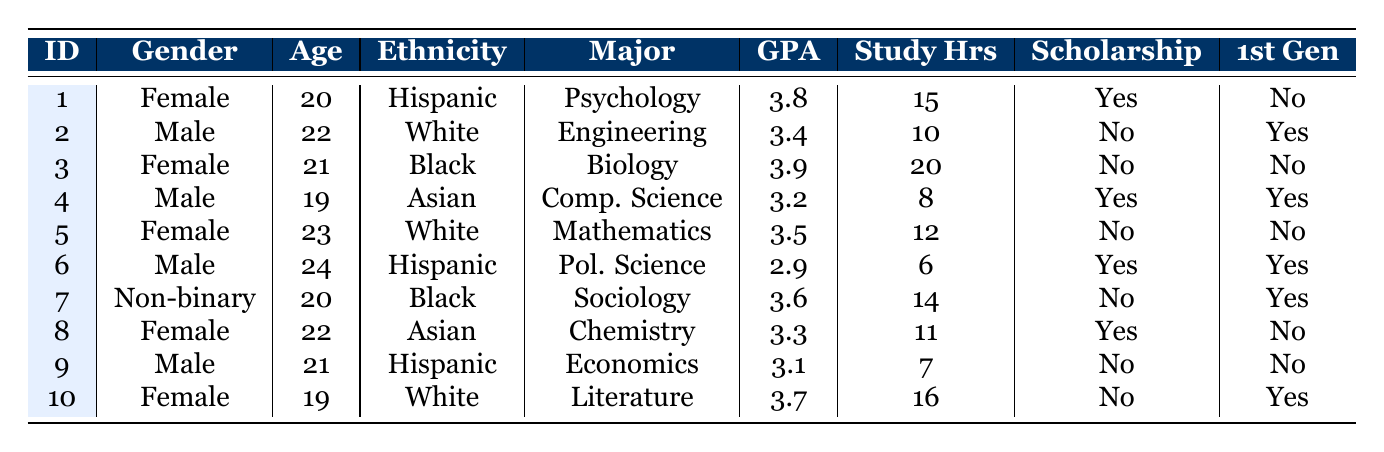What is the GPA of the student majoring in Psychology? From the table, the student with a major in Psychology is student_id 1, whose GPA is listed as 3.8.
Answer: 3.8 How many students have a GPA above 3.5? By examining the GPAs, students 1, 3, 5, 7, and 10 have GPAs above 3.5. This gives a total of 5 students.
Answer: 5 Is there a female student who has a scholarship? Looking at the data, student_id 1 (Female, 3.8 GPA) and student_id 8 (Female, 3.3 GPA) are the only females; only student_id 1 has a scholarship.
Answer: Yes What percentage of male students are first-generation college students? There are 4 male students (students 2, 4, 6, and 9) in total. Out of these, students 2 and 6 are first-generation college students, which is 2 out of 4, equating to 50%.
Answer: 50% What is the average number of study hours for students with a scholarship? The students with a scholarship are student_ids 1, 4, 6, and 8, who study for 15, 8, 6, and 11 hours respectively. Summing these gives 15 + 8 + 6 + 11 = 40 hours. The average is 40/4 = 10 hours.
Answer: 10 Which gender has the highest average GPA? Calculating the GPAs: Males (2.9, 3.4, 3.2, 3.1) average to 3.15; Females (3.8, 3.9, 3.5, 3.7) average to 3.735; Non-binary (3.6) gives an overall average of 3.735 for females, which is higher than the male average of 3.15.
Answer: Female How many first-generation college students have a GPA below 3.0? The students who are first-generation are 2, 4, 6, and 7. Among these, only student_id 6 has a GPA below 3.0 (GPA = 2.9). Therefore, there is 1 student below this threshold.
Answer: 1 What is the age of the student with the lowest GPA? The student with the lowest GPA is student_id 6, who is 24 years old.
Answer: 24 How does the GPA of scholarship students compare to non-scholarship students? Scholarship students have GPAs of 3.8, 3.2, 2.9, and 3.3, averaging to (3.8 + 3.2 + 2.9 + 3.3) / 4 = 3.3. Non-scholarship students' GPAs are 3.9, 3.5, 3.6, 3.1, and 3.7, averaging to (3.9 + 3.5 + 3.6 + 3.1 + 3.7) / 5 = 3.54. Thus, non-scholarship students have a higher average GPA.
Answer: Non-scholarship students have a higher average GPA What is the most common major among the students? To determine the most common major, we can count each major: Psychology (1), Engineering (1), Biology (1), Computer Science (1), Mathematics (1), Political Science (1), Sociology (1), Chemistry (1), Economics (1), Literature (1). Each appears once, thus there isn't a dominant major in this data set.
Answer: No dominant major 